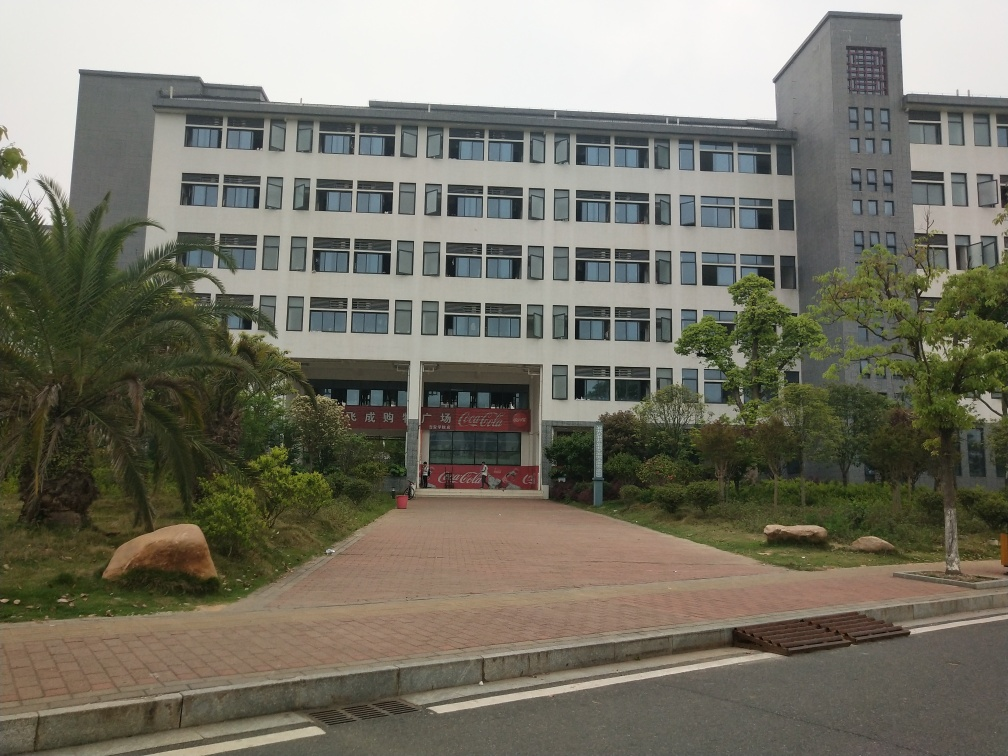What kind of building is shown in this image? The building appears to be an institutional structure, possibly an educational or corporate facility, given its large, symmetrical facade and formal design. Are there any signs or logos in the image that indicate what the building is used for? There's red signage visible above the entrance with text, which suggests the building could be named after or affiliated with a specific entity. However, the exact purpose of the building isn't clear without a closer examination of the sign's text. 